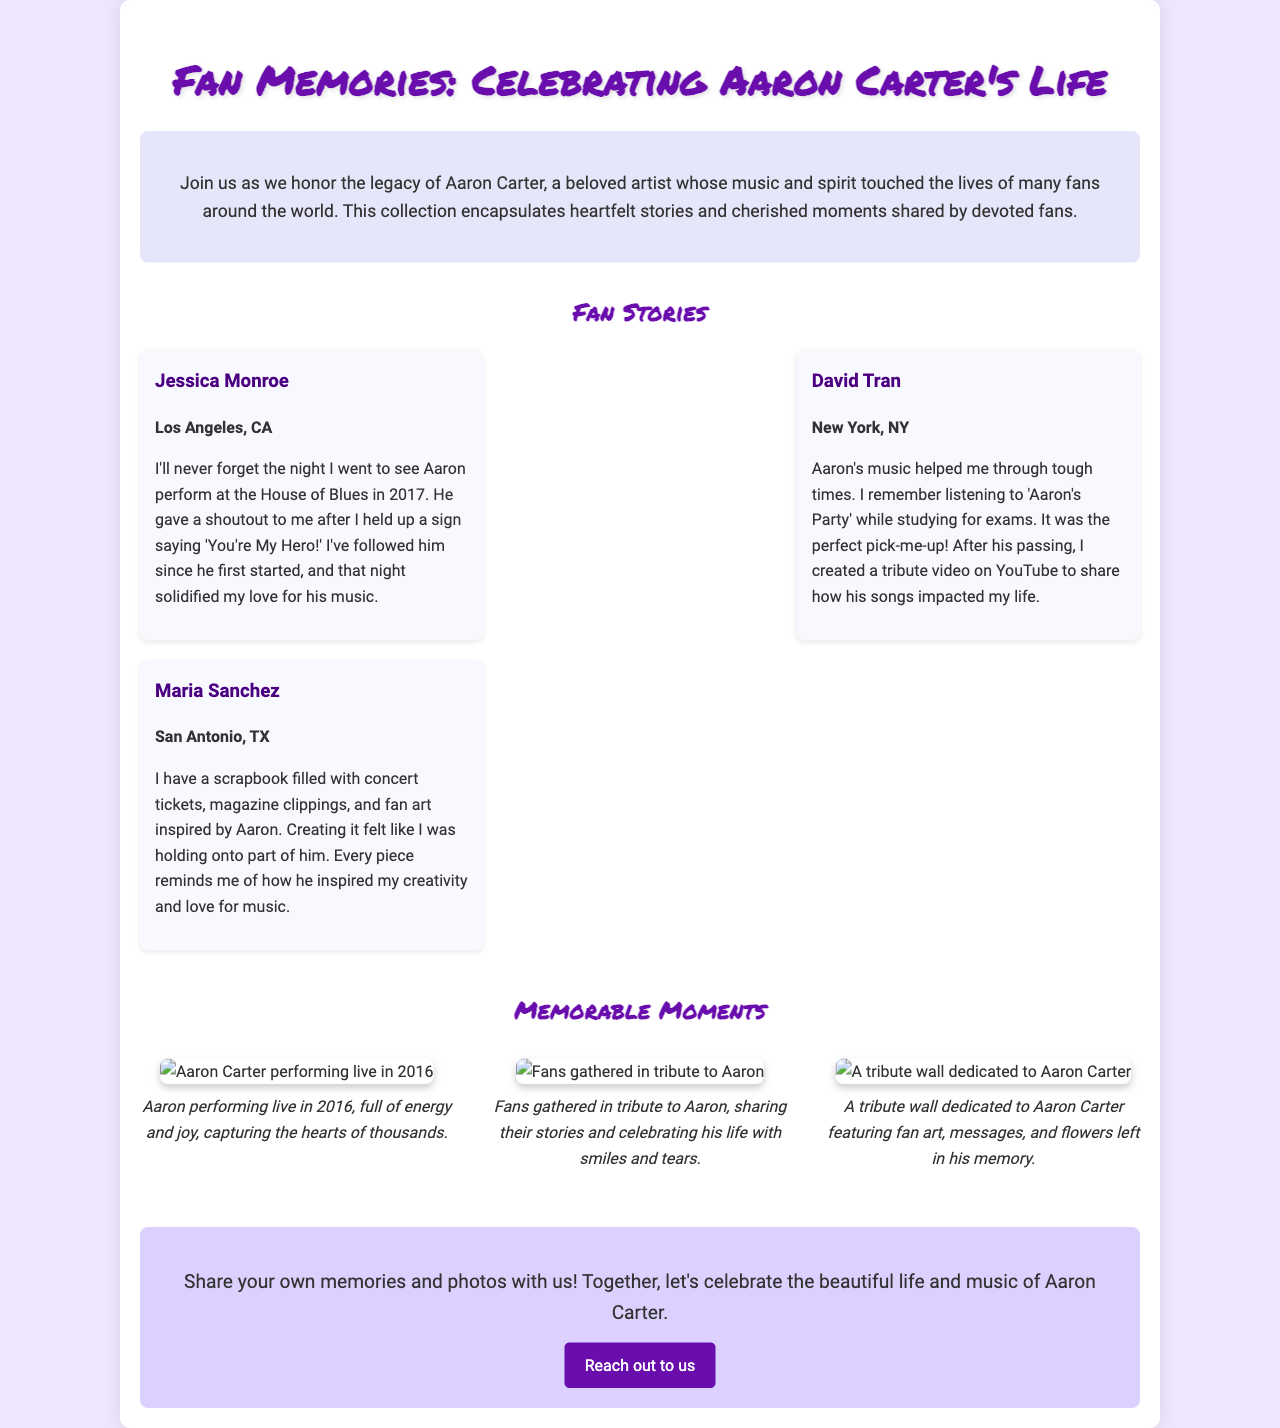What is the title of the brochure? The title is prominently displayed at the top of the document.
Answer: Fan Memories: Celebrating Aaron Carter's Life How many fan stories are featured in the document? The document lists three individual fan stories.
Answer: 3 What city is Jessica Monroe from? Jessica Monroe's location is mentioned beneath her name in the story section.
Answer: Los Angeles, CA What year did Jessica see Aaron perform? The year of the performance is stated in her fan story.
Answer: 2017 What type of items does Maria Sanchez have in her scrapbook? The types of items are detailed in Maria's story.
Answer: Concert tickets, magazine clippings, and fan art What is suggested for fans to share in the document? This suggestion is made in the call-to-action section at the end.
Answer: Memories and photos What event is depicted in the photo titled "Fans gathered in tribute to Aaron"? The caption for this photo describes the gathering context.
Answer: Tribute to Aaron In what year was the tribute wall dedicated? The year is noted in the caption of the corresponding photo.
Answer: 2023 